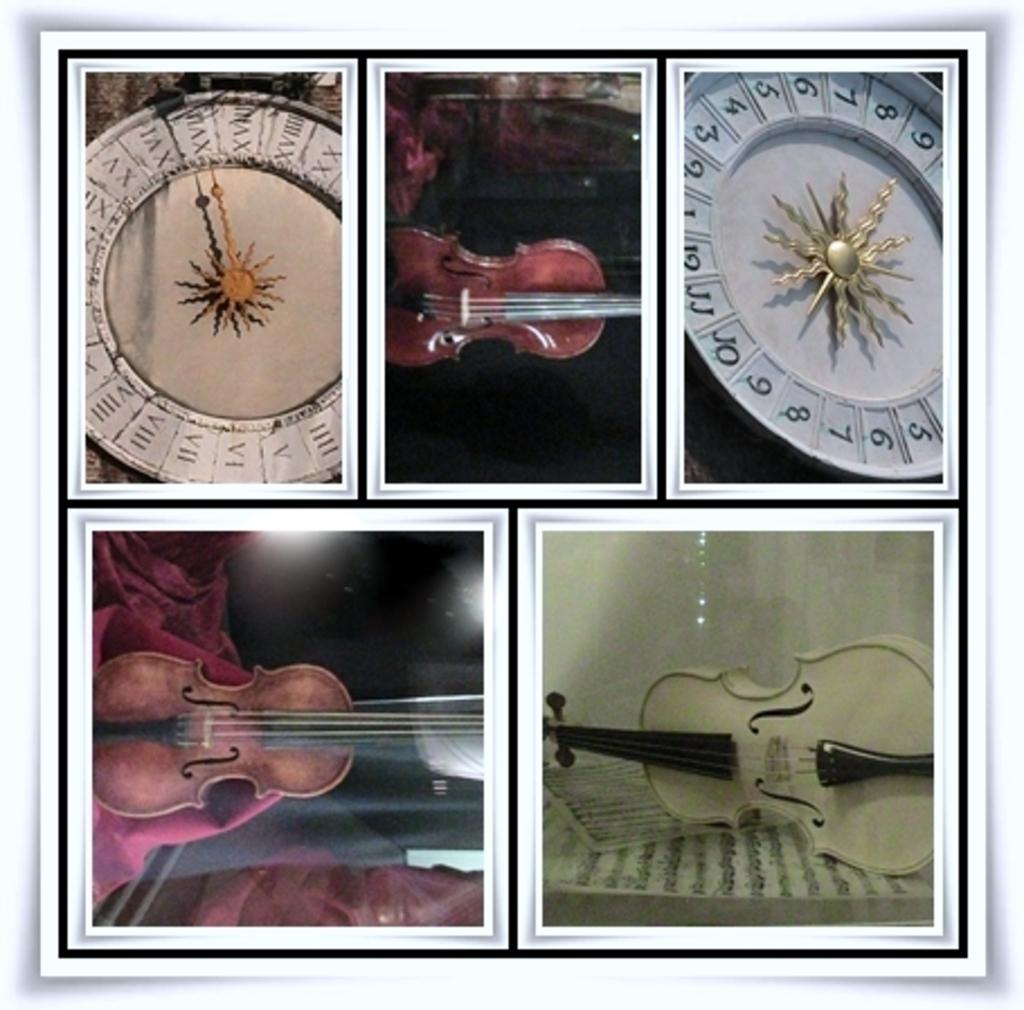What objects are present in the image that are related to time? There are clocks in the image. What other objects can be seen in the image? There are musical instruments in the image. What type of ear is visible on the musical instrument in the image? There is no ear present on any musical instrument in the image. Where is the meeting taking place in the image? There is no meeting depicted in the image; it only features clocks and musical instruments. 